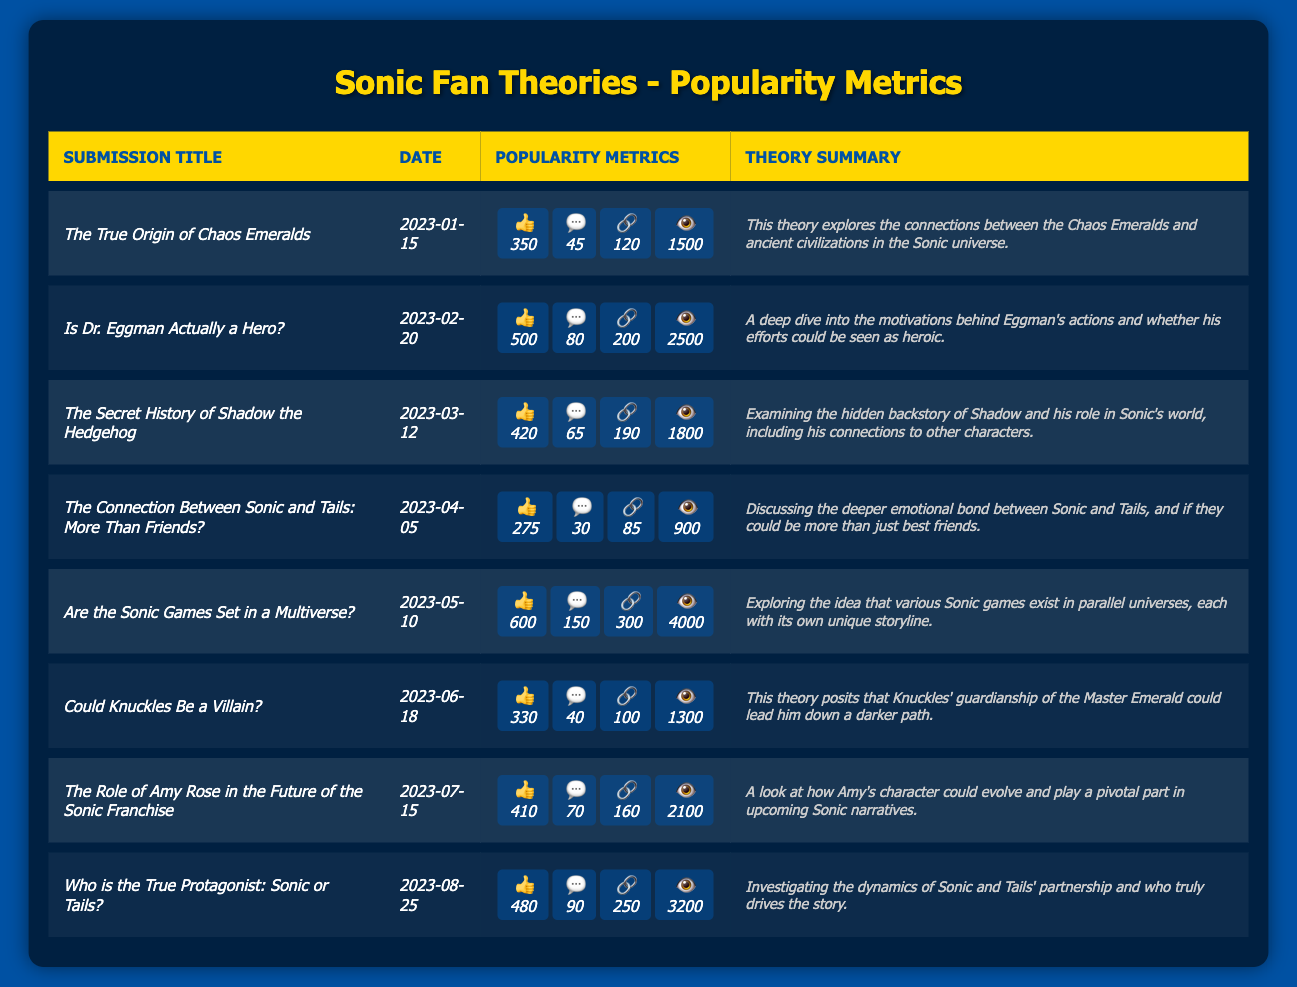What is the submission title with the most likes? The submission titled "*Are the Sonic Games Set in a Multiverse?*" has the highest number of likes at 600.
Answer: Are the Sonic Games Set in a Multiverse? What is the total number of comments across all submissions? To find the total comments, add them up: (45 + 80 + 65 + 30 + 150 + 40 + 70 + 90) = 570.
Answer: 570 Which submission had the least number of views? The submission "*The Connection Between Sonic and Tails: More Than Friends?*" recorded the least views with 900.
Answer: The Connection Between Sonic and Tails: More Than Friends? How many shares did the theory about Knuckles receive? The submission titled "*Could Knuckles Be a Villain?*" received a total of 100 shares.
Answer: 100 What is the average number of likes for all submissions? The total likes are (350 + 500 + 420 + 275 + 600 + 330 + 410 + 480) = 3865. Dividing by 8 submissions gives an average of 3865 / 8 = 483.125, which can be rounded to 483.
Answer: 483 Which submission had the highest number of shares? The submission "*Are the Sonic Games Set in a Multiverse?*" had the highest shares with 300.
Answer: Are the Sonic Games Set in a Multiverse? Is there a submission related to Shadow? Yes, the submission titled "*The Secret History of Shadow the Hedgehog*" relates to Shadow.
Answer: Yes What is the difference in views between the most and least popular theories? The most popular theory "Are the Sonic Games Set in a Multiverse?" had 4000 views, while the least popular, "The Connection Between Sonic and Tails," had 900 views. The difference is 4000 - 900 = 3100.
Answer: 3100 How many theories received more than 400 likes? The submissions with more than 400 likes are "*Is Dr. Eggman Actually a Hero?*", "*The Secret History of Shadow the Hedgehog*", "*Are the Sonic Games Set in a Multiverse?*", "*Who is the True Protagonist: Sonic or Tails?*" totaling 4 theories.
Answer: 4 What percentage of comments were made on the submission about Eggman? The total comments are 570. The comments on the Eggman submission are 80. The percentage is (80 / 570) * 100 = 14.04%, which rounds to 14%.
Answer: 14% 